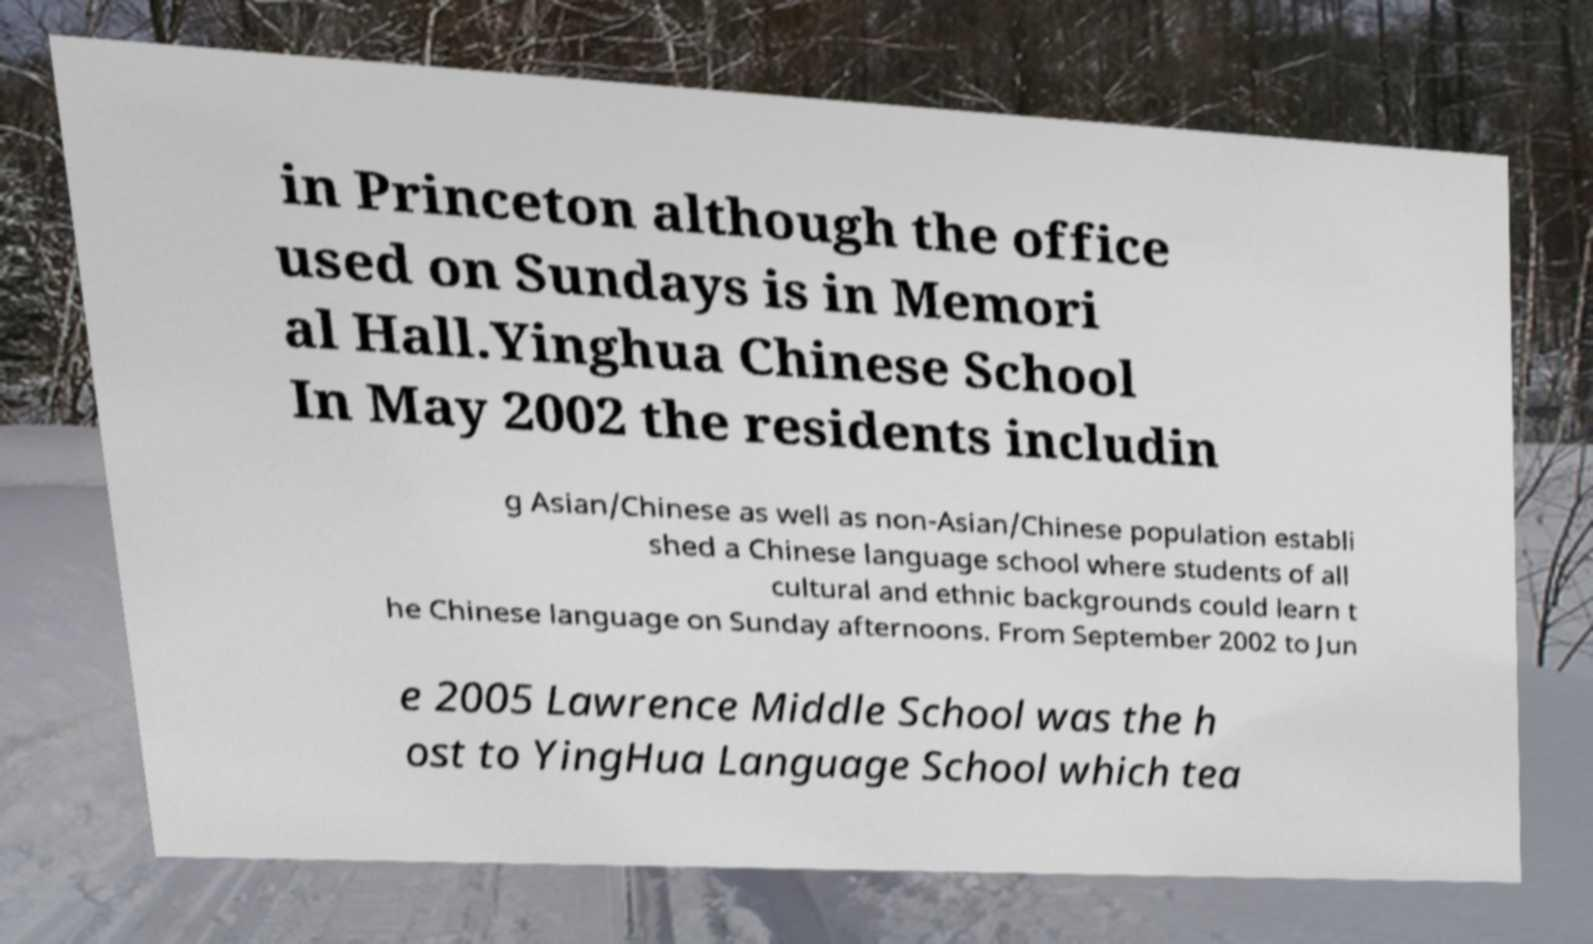There's text embedded in this image that I need extracted. Can you transcribe it verbatim? in Princeton although the office used on Sundays is in Memori al Hall.Yinghua Chinese School In May 2002 the residents includin g Asian/Chinese as well as non-Asian/Chinese population establi shed a Chinese language school where students of all cultural and ethnic backgrounds could learn t he Chinese language on Sunday afternoons. From September 2002 to Jun e 2005 Lawrence Middle School was the h ost to YingHua Language School which tea 